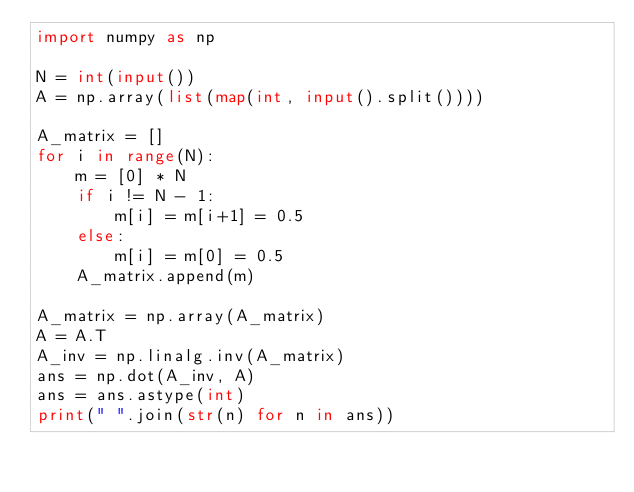Convert code to text. <code><loc_0><loc_0><loc_500><loc_500><_Python_>import numpy as np

N = int(input())
A = np.array(list(map(int, input().split())))

A_matrix = []
for i in range(N):
    m = [0] * N
    if i != N - 1:
        m[i] = m[i+1] = 0.5
    else:
        m[i] = m[0] = 0.5
    A_matrix.append(m)

A_matrix = np.array(A_matrix)
A = A.T
A_inv = np.linalg.inv(A_matrix)
ans = np.dot(A_inv, A)
ans = ans.astype(int)
print(" ".join(str(n) for n in ans))</code> 